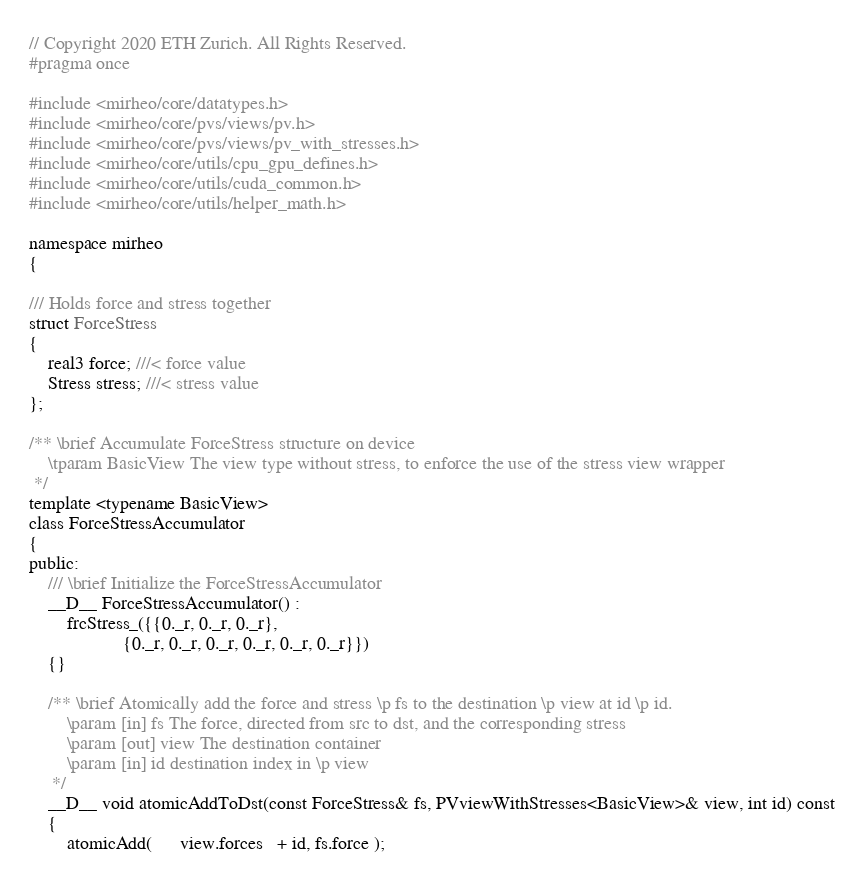Convert code to text. <code><loc_0><loc_0><loc_500><loc_500><_C_>// Copyright 2020 ETH Zurich. All Rights Reserved.
#pragma once

#include <mirheo/core/datatypes.h>
#include <mirheo/core/pvs/views/pv.h>
#include <mirheo/core/pvs/views/pv_with_stresses.h>
#include <mirheo/core/utils/cpu_gpu_defines.h>
#include <mirheo/core/utils/cuda_common.h>
#include <mirheo/core/utils/helper_math.h>

namespace mirheo
{

/// Holds force and stress together
struct ForceStress
{
    real3 force; ///< force value
    Stress stress; ///< stress value
};

/** \brief Accumulate ForceStress structure on device
    \tparam BasicView The view type without stress, to enforce the use of the stress view wrapper
 */
template <typename BasicView>
class ForceStressAccumulator
{
public:
    /// \brief Initialize the ForceStressAccumulator
    __D__ ForceStressAccumulator() :
        frcStress_({{0._r, 0._r, 0._r},
                    {0._r, 0._r, 0._r, 0._r, 0._r, 0._r}})
    {}

    /** \brief Atomically add the force and stress \p fs to the destination \p view at id \p id.
        \param [in] fs The force, directed from src to dst, and the corresponding stress
        \param [out] view The destination container
        \param [in] id destination index in \p view
     */
    __D__ void atomicAddToDst(const ForceStress& fs, PVviewWithStresses<BasicView>& view, int id) const
    {
        atomicAdd(      view.forces   + id, fs.force );</code> 